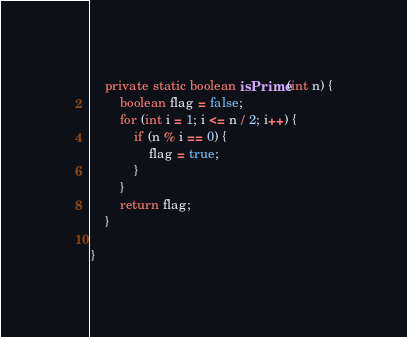Convert code to text. <code><loc_0><loc_0><loc_500><loc_500><_Java_>
    private static boolean isPrime(int n) {
        boolean flag = false;
        for (int i = 1; i <= n / 2; i++) {
            if (n % i == 0) {
                flag = true;
            }
        }
        return flag;
    }

}
</code> 